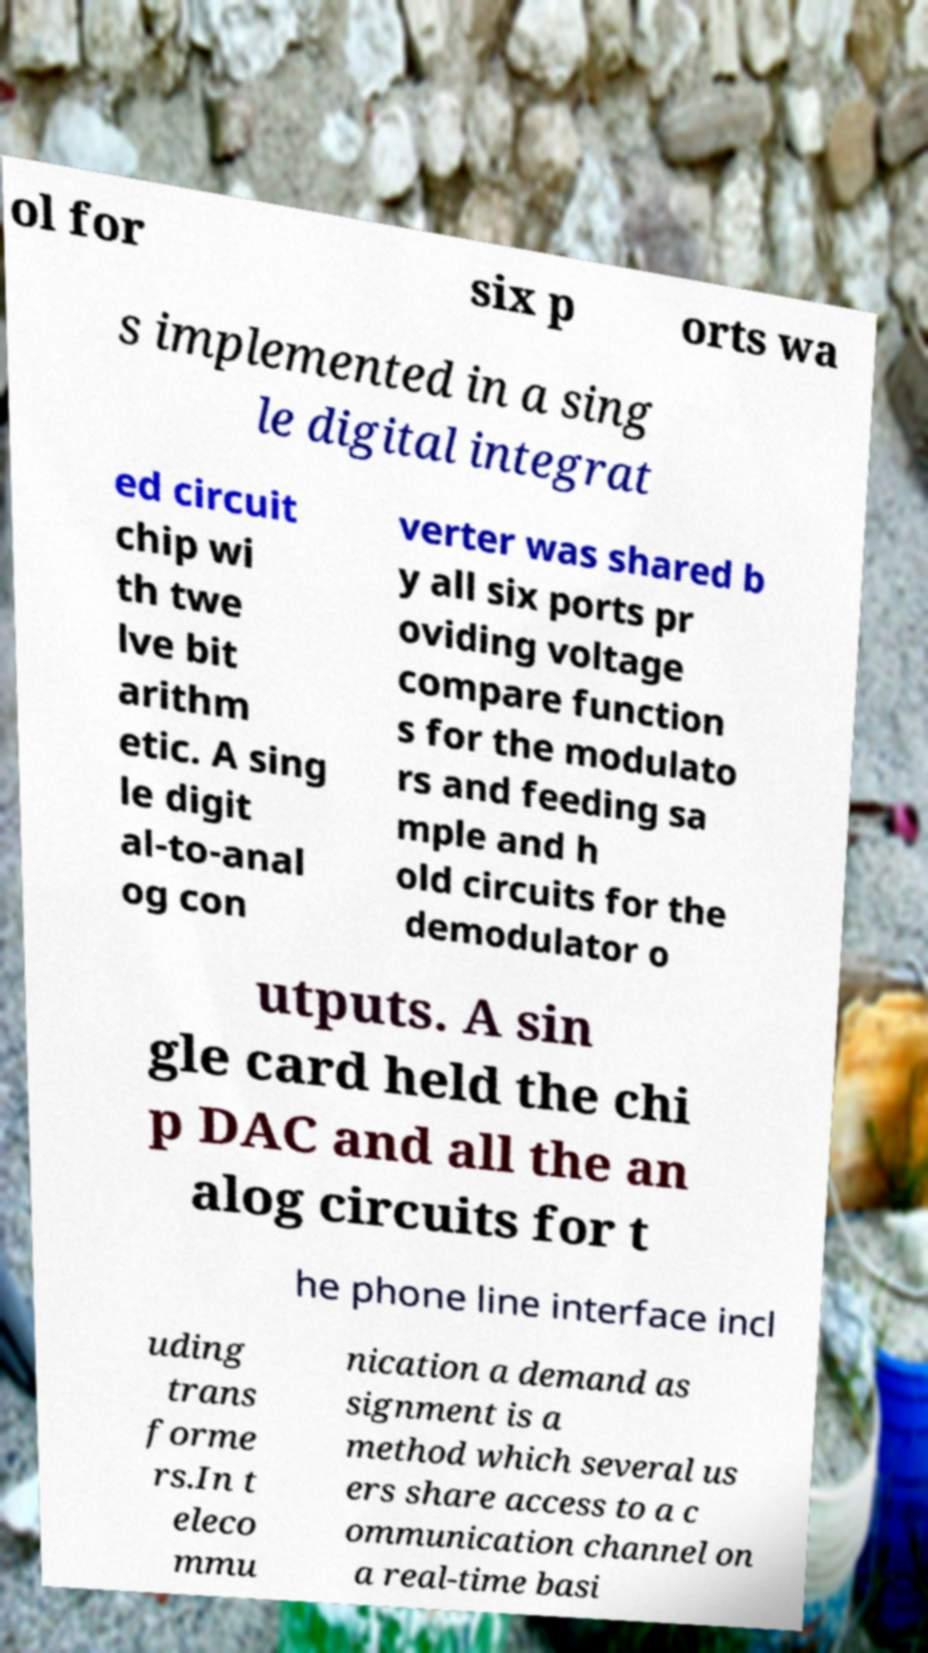For documentation purposes, I need the text within this image transcribed. Could you provide that? ol for six p orts wa s implemented in a sing le digital integrat ed circuit chip wi th twe lve bit arithm etic. A sing le digit al-to-anal og con verter was shared b y all six ports pr oviding voltage compare function s for the modulato rs and feeding sa mple and h old circuits for the demodulator o utputs. A sin gle card held the chi p DAC and all the an alog circuits for t he phone line interface incl uding trans forme rs.In t eleco mmu nication a demand as signment is a method which several us ers share access to a c ommunication channel on a real-time basi 